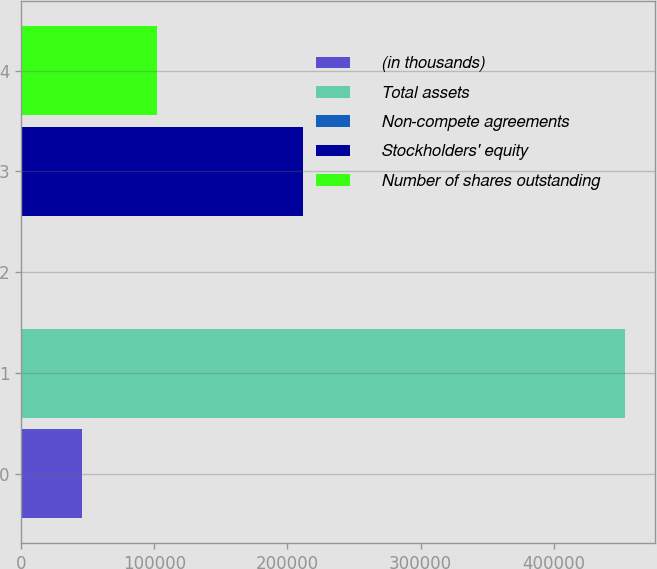Convert chart to OTSL. <chart><loc_0><loc_0><loc_500><loc_500><bar_chart><fcel>(in thousands)<fcel>Total assets<fcel>Non-compete agreements<fcel>Stockholders' equity<fcel>Number of shares outstanding<nl><fcel>45911.5<fcel>453175<fcel>660<fcel>211459<fcel>101837<nl></chart> 